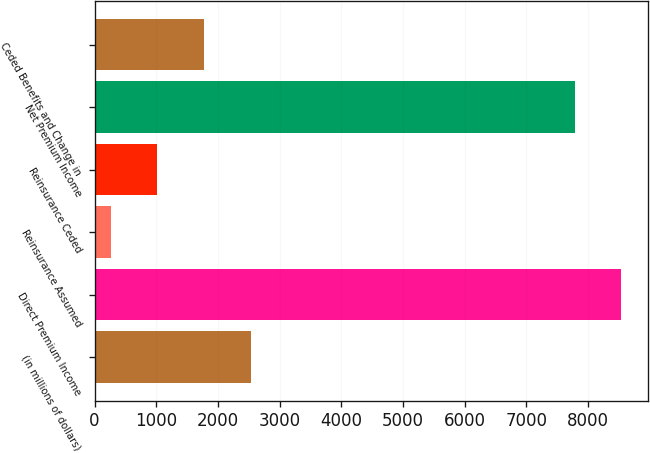Convert chart to OTSL. <chart><loc_0><loc_0><loc_500><loc_500><bar_chart><fcel>(in millions of dollars)<fcel>Direct Premium Income<fcel>Reinsurance Assumed<fcel>Reinsurance Ceded<fcel>Net Premium Income<fcel>Ceded Benefits and Change in<nl><fcel>2530.21<fcel>8538.57<fcel>264.4<fcel>1019.67<fcel>7783.3<fcel>1774.94<nl></chart> 